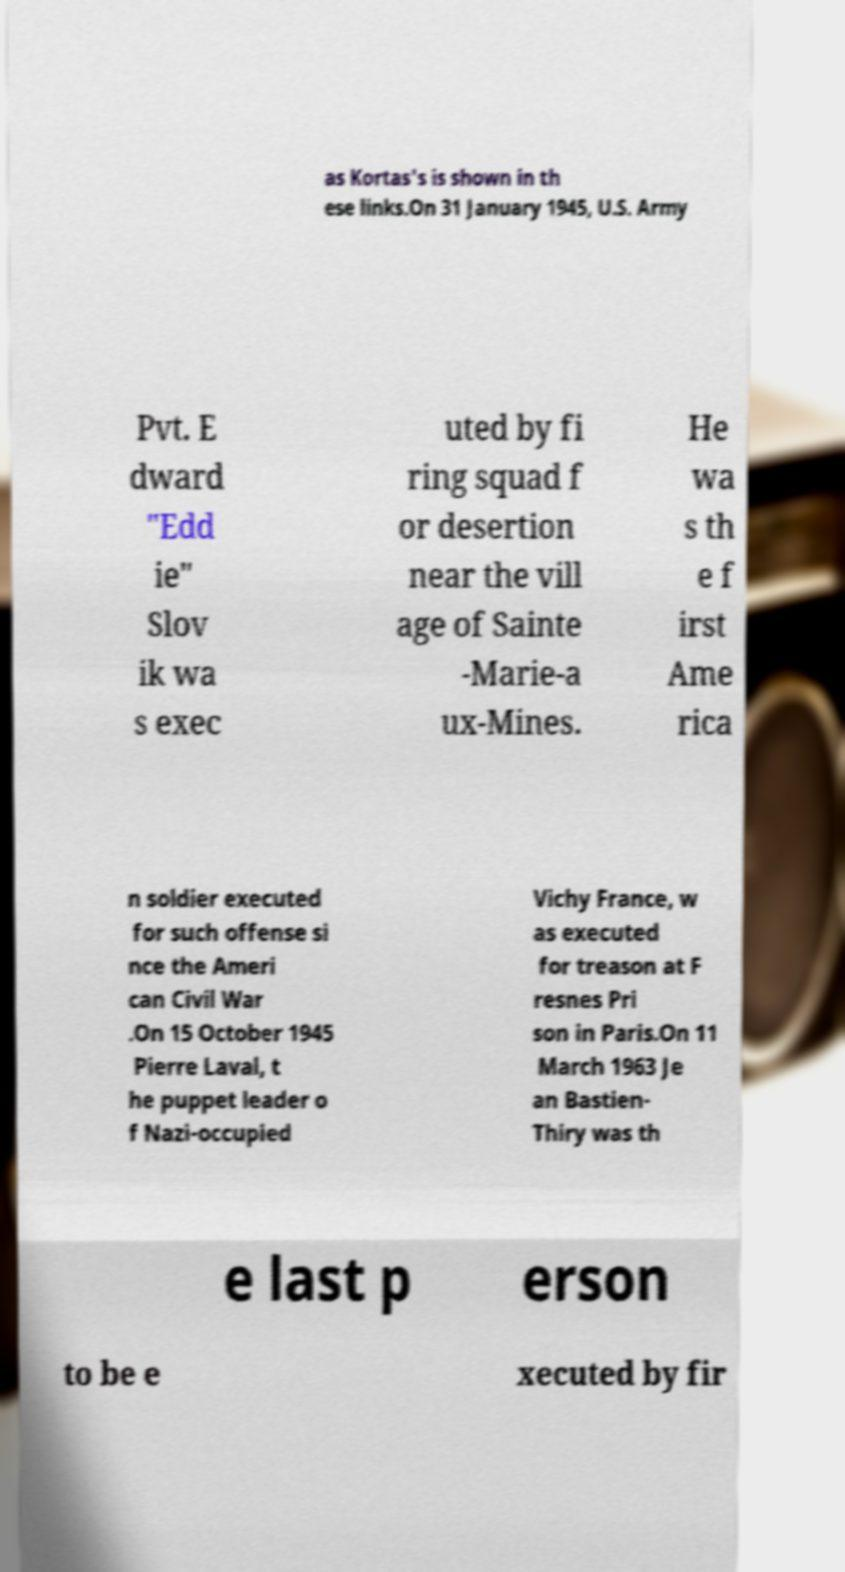Can you read and provide the text displayed in the image?This photo seems to have some interesting text. Can you extract and type it out for me? as Kortas's is shown in th ese links.On 31 January 1945, U.S. Army Pvt. E dward "Edd ie" Slov ik wa s exec uted by fi ring squad f or desertion near the vill age of Sainte -Marie-a ux-Mines. He wa s th e f irst Ame rica n soldier executed for such offense si nce the Ameri can Civil War .On 15 October 1945 Pierre Laval, t he puppet leader o f Nazi-occupied Vichy France, w as executed for treason at F resnes Pri son in Paris.On 11 March 1963 Je an Bastien- Thiry was th e last p erson to be e xecuted by fir 